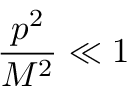Convert formula to latex. <formula><loc_0><loc_0><loc_500><loc_500>\frac { p ^ { 2 } } { M ^ { 2 } } \ll 1</formula> 